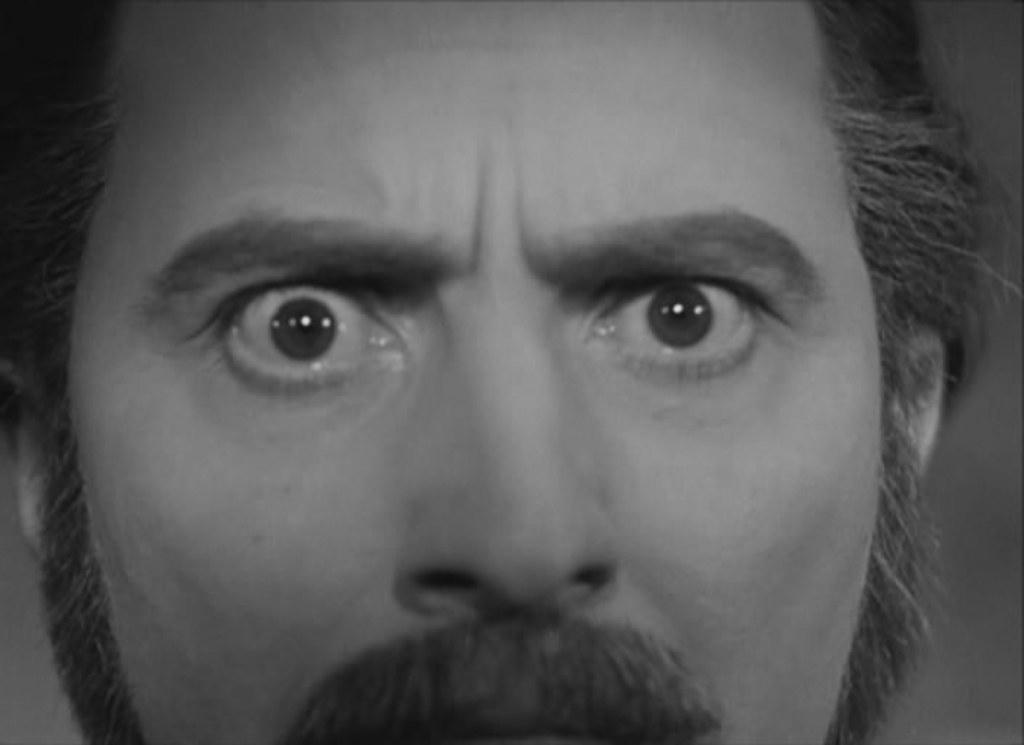What is the color scheme of the image? The image is black and white. Can you describe the person in the image? There is a man in the image. What is the man doing in the image? The man is staring in the front. What type of snake is wrapped around the man's neck in the image? There is no snake present in the image; it only features a man staring in the front. 